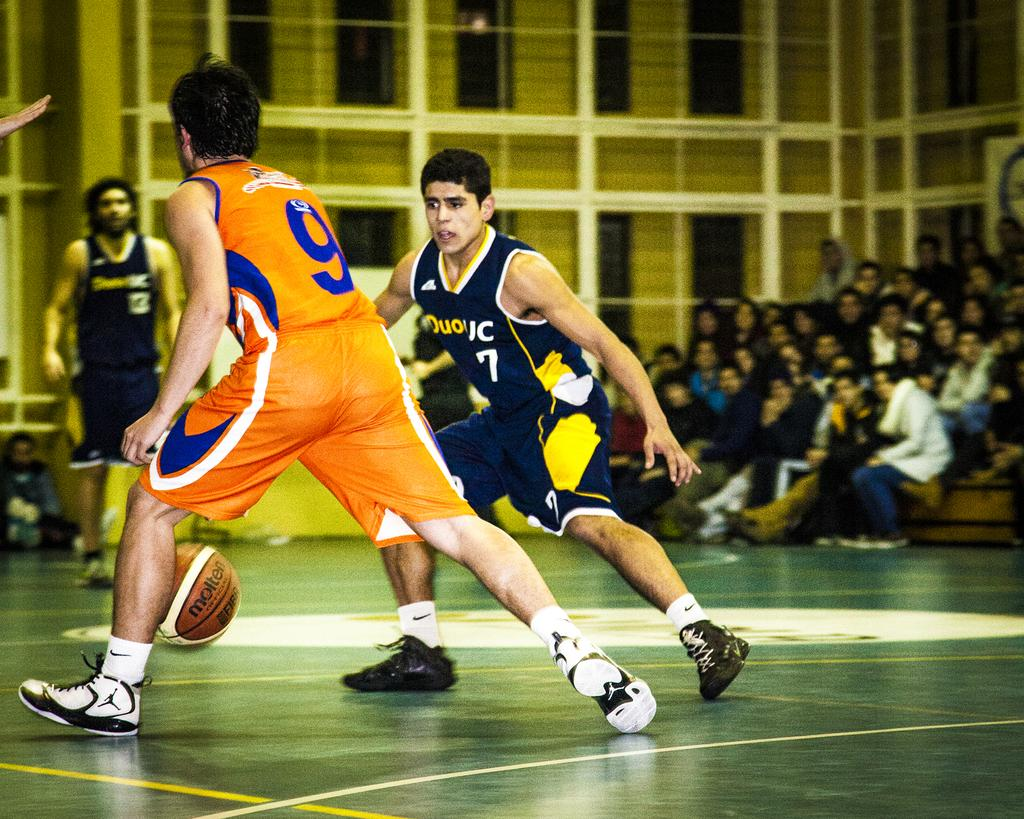<image>
Relay a brief, clear account of the picture shown. Player number 9 is dribbling the basketball on the court. 